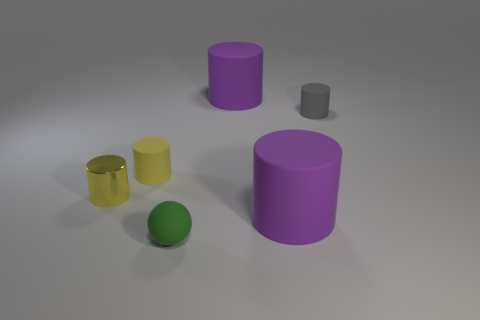Subtract all gray cylinders. How many cylinders are left? 4 Subtract all yellow matte cylinders. How many cylinders are left? 4 Subtract all green cylinders. Subtract all cyan spheres. How many cylinders are left? 5 Add 3 big cylinders. How many objects exist? 9 Subtract all balls. How many objects are left? 5 Subtract 0 blue spheres. How many objects are left? 6 Subtract all small matte objects. Subtract all big gray metallic spheres. How many objects are left? 3 Add 4 tiny green objects. How many tiny green objects are left? 5 Add 2 cyan rubber blocks. How many cyan rubber blocks exist? 2 